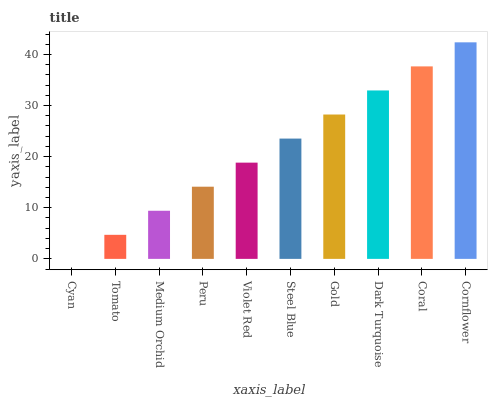Is Cyan the minimum?
Answer yes or no. Yes. Is Cornflower the maximum?
Answer yes or no. Yes. Is Tomato the minimum?
Answer yes or no. No. Is Tomato the maximum?
Answer yes or no. No. Is Tomato greater than Cyan?
Answer yes or no. Yes. Is Cyan less than Tomato?
Answer yes or no. Yes. Is Cyan greater than Tomato?
Answer yes or no. No. Is Tomato less than Cyan?
Answer yes or no. No. Is Steel Blue the high median?
Answer yes or no. Yes. Is Violet Red the low median?
Answer yes or no. Yes. Is Cyan the high median?
Answer yes or no. No. Is Cyan the low median?
Answer yes or no. No. 